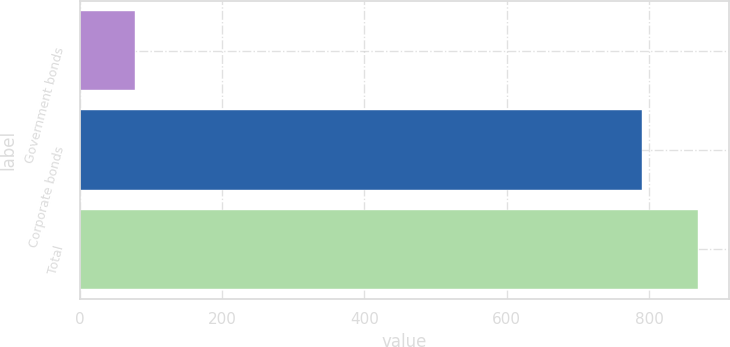<chart> <loc_0><loc_0><loc_500><loc_500><bar_chart><fcel>Government bonds<fcel>Corporate bonds<fcel>Total<nl><fcel>77<fcel>790<fcel>869<nl></chart> 